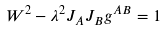<formula> <loc_0><loc_0><loc_500><loc_500>W ^ { 2 } - \lambda ^ { 2 } J _ { A } J _ { B } g ^ { A B } = 1</formula> 